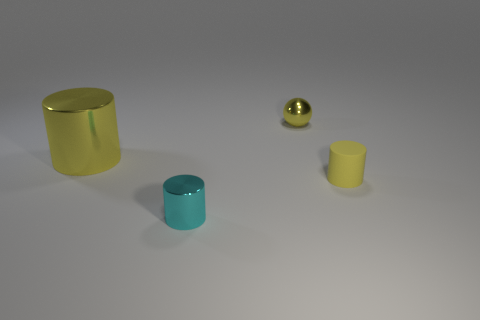What is the color of the big metallic cylinder?
Your answer should be compact. Yellow. What color is the small metal thing behind the small cylinder that is behind the cylinder in front of the small matte object?
Your answer should be compact. Yellow. Do the large object and the tiny shiny object that is to the right of the small cyan shiny cylinder have the same shape?
Make the answer very short. No. What is the color of the small thing that is both in front of the large yellow cylinder and right of the small cyan thing?
Make the answer very short. Yellow. Are there any metallic things that have the same shape as the rubber thing?
Keep it short and to the point. Yes. Does the small metallic cylinder have the same color as the shiny ball?
Provide a succinct answer. No. Is there a metallic thing behind the yellow object that is behind the big yellow thing?
Your answer should be very brief. No. How many objects are shiny objects that are behind the large yellow thing or small metallic things that are on the right side of the cyan cylinder?
Ensure brevity in your answer.  1. What number of objects are yellow metallic balls or big metallic cylinders that are left of the small yellow shiny object?
Offer a terse response. 2. How big is the yellow ball on the left side of the yellow cylinder in front of the yellow object to the left of the yellow metallic ball?
Offer a terse response. Small. 